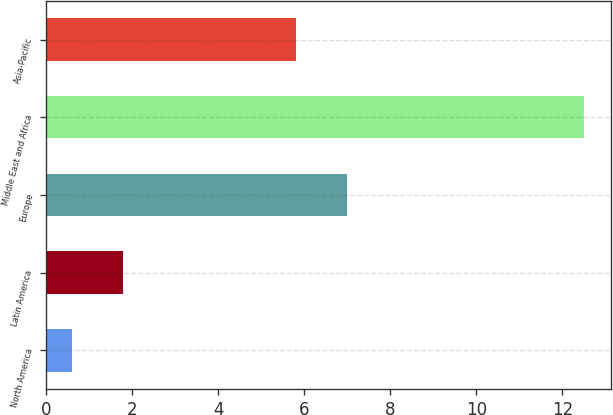Convert chart to OTSL. <chart><loc_0><loc_0><loc_500><loc_500><bar_chart><fcel>North America<fcel>Latin America<fcel>Europe<fcel>Middle East and Africa<fcel>Asia-Pacific<nl><fcel>0.6<fcel>1.79<fcel>7<fcel>12.5<fcel>5.8<nl></chart> 